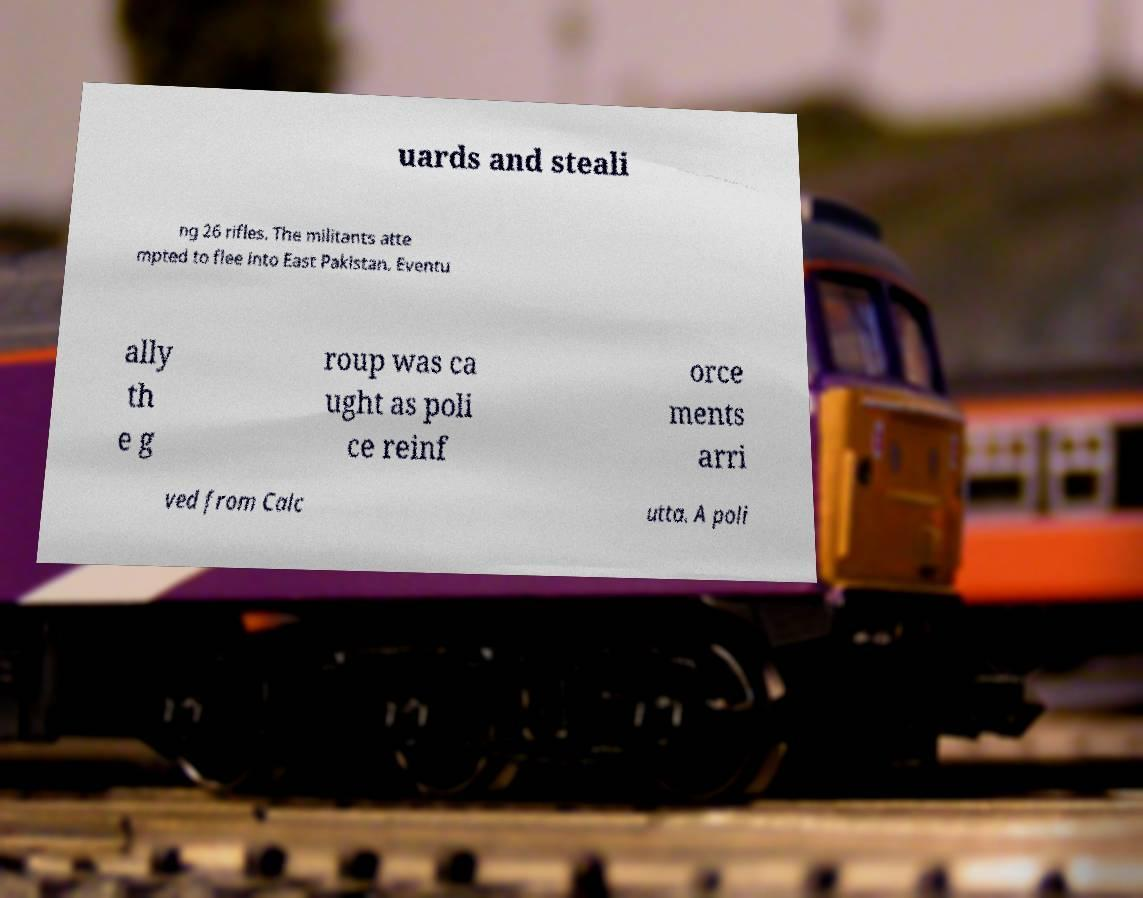Can you accurately transcribe the text from the provided image for me? uards and steali ng 26 rifles. The militants atte mpted to flee into East Pakistan. Eventu ally th e g roup was ca ught as poli ce reinf orce ments arri ved from Calc utta. A poli 